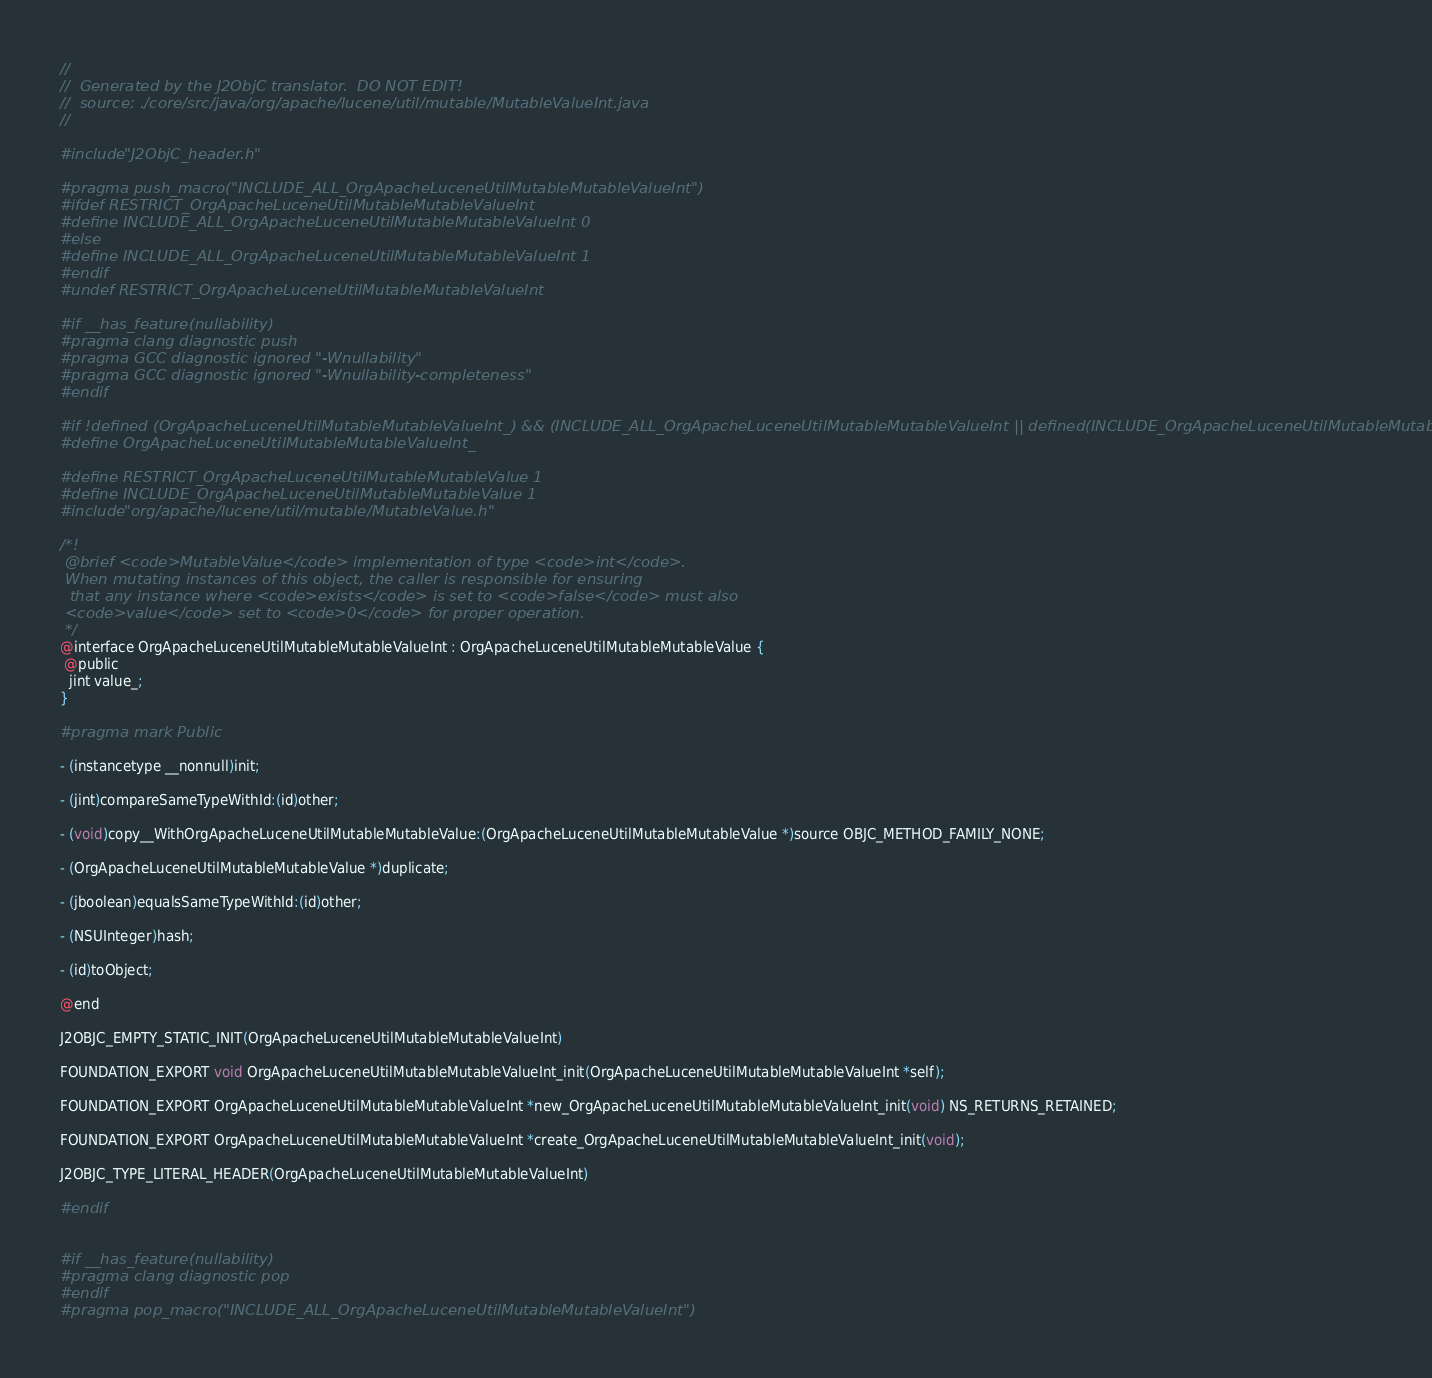Convert code to text. <code><loc_0><loc_0><loc_500><loc_500><_C_>//
//  Generated by the J2ObjC translator.  DO NOT EDIT!
//  source: ./core/src/java/org/apache/lucene/util/mutable/MutableValueInt.java
//

#include "J2ObjC_header.h"

#pragma push_macro("INCLUDE_ALL_OrgApacheLuceneUtilMutableMutableValueInt")
#ifdef RESTRICT_OrgApacheLuceneUtilMutableMutableValueInt
#define INCLUDE_ALL_OrgApacheLuceneUtilMutableMutableValueInt 0
#else
#define INCLUDE_ALL_OrgApacheLuceneUtilMutableMutableValueInt 1
#endif
#undef RESTRICT_OrgApacheLuceneUtilMutableMutableValueInt

#if __has_feature(nullability)
#pragma clang diagnostic push
#pragma GCC diagnostic ignored "-Wnullability"
#pragma GCC diagnostic ignored "-Wnullability-completeness"
#endif

#if !defined (OrgApacheLuceneUtilMutableMutableValueInt_) && (INCLUDE_ALL_OrgApacheLuceneUtilMutableMutableValueInt || defined(INCLUDE_OrgApacheLuceneUtilMutableMutableValueInt))
#define OrgApacheLuceneUtilMutableMutableValueInt_

#define RESTRICT_OrgApacheLuceneUtilMutableMutableValue 1
#define INCLUDE_OrgApacheLuceneUtilMutableMutableValue 1
#include "org/apache/lucene/util/mutable/MutableValue.h"

/*!
 @brief <code>MutableValue</code> implementation of type <code>int</code>.
 When mutating instances of this object, the caller is responsible for ensuring 
  that any instance where <code>exists</code> is set to <code>false</code> must also  
 <code>value</code> set to <code>0</code> for proper operation.
 */
@interface OrgApacheLuceneUtilMutableMutableValueInt : OrgApacheLuceneUtilMutableMutableValue {
 @public
  jint value_;
}

#pragma mark Public

- (instancetype __nonnull)init;

- (jint)compareSameTypeWithId:(id)other;

- (void)copy__WithOrgApacheLuceneUtilMutableMutableValue:(OrgApacheLuceneUtilMutableMutableValue *)source OBJC_METHOD_FAMILY_NONE;

- (OrgApacheLuceneUtilMutableMutableValue *)duplicate;

- (jboolean)equalsSameTypeWithId:(id)other;

- (NSUInteger)hash;

- (id)toObject;

@end

J2OBJC_EMPTY_STATIC_INIT(OrgApacheLuceneUtilMutableMutableValueInt)

FOUNDATION_EXPORT void OrgApacheLuceneUtilMutableMutableValueInt_init(OrgApacheLuceneUtilMutableMutableValueInt *self);

FOUNDATION_EXPORT OrgApacheLuceneUtilMutableMutableValueInt *new_OrgApacheLuceneUtilMutableMutableValueInt_init(void) NS_RETURNS_RETAINED;

FOUNDATION_EXPORT OrgApacheLuceneUtilMutableMutableValueInt *create_OrgApacheLuceneUtilMutableMutableValueInt_init(void);

J2OBJC_TYPE_LITERAL_HEADER(OrgApacheLuceneUtilMutableMutableValueInt)

#endif


#if __has_feature(nullability)
#pragma clang diagnostic pop
#endif
#pragma pop_macro("INCLUDE_ALL_OrgApacheLuceneUtilMutableMutableValueInt")
</code> 